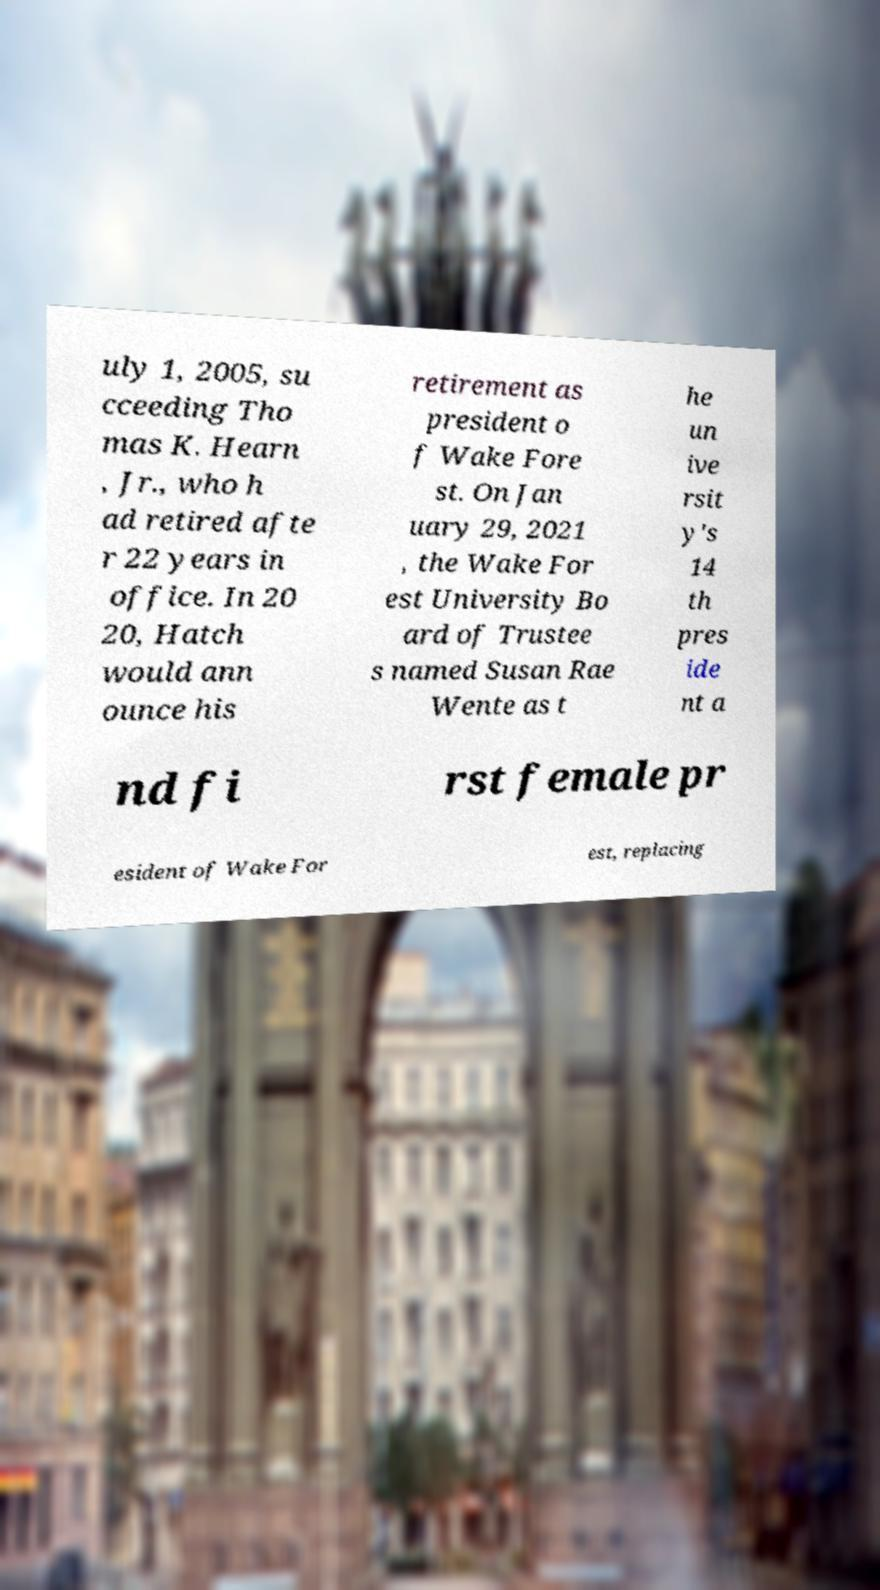Can you accurately transcribe the text from the provided image for me? uly 1, 2005, su cceeding Tho mas K. Hearn , Jr., who h ad retired afte r 22 years in office. In 20 20, Hatch would ann ounce his retirement as president o f Wake Fore st. On Jan uary 29, 2021 , the Wake For est University Bo ard of Trustee s named Susan Rae Wente as t he un ive rsit y's 14 th pres ide nt a nd fi rst female pr esident of Wake For est, replacing 